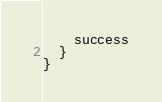<code> <loc_0><loc_0><loc_500><loc_500><_Scala_>    success
  }
}
</code> 